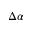Convert formula to latex. <formula><loc_0><loc_0><loc_500><loc_500>\Delta \alpha</formula> 